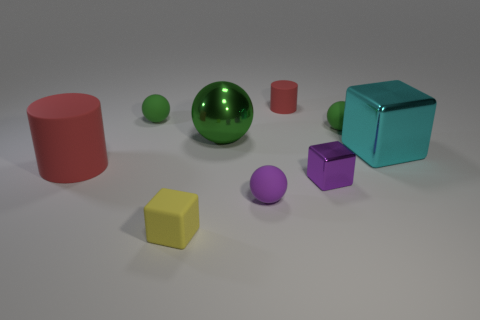Subtract all green cubes. How many green balls are left? 3 Subtract all balls. How many objects are left? 5 Add 5 yellow metal cylinders. How many yellow metal cylinders exist? 5 Subtract 1 red cylinders. How many objects are left? 8 Subtract all red matte objects. Subtract all red matte cylinders. How many objects are left? 5 Add 1 large green metallic balls. How many large green metallic balls are left? 2 